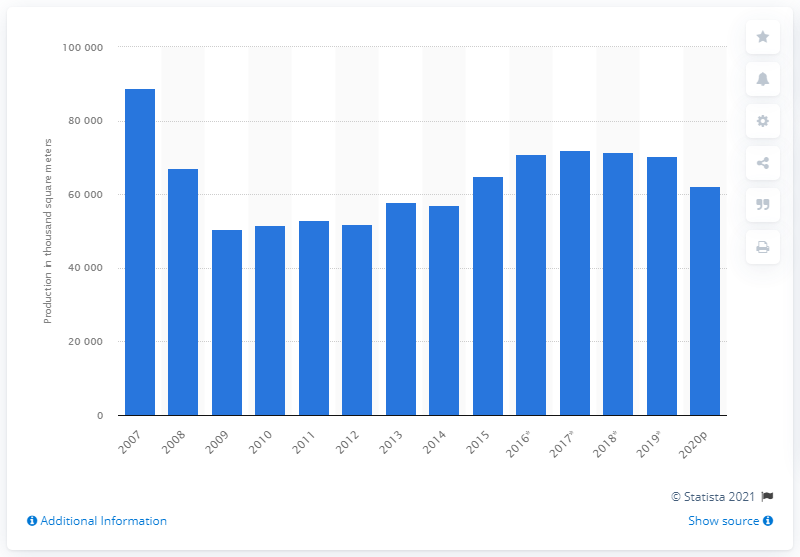Identify some key points in this picture. In 2007, the production rate of concrete blocks began to recover. 